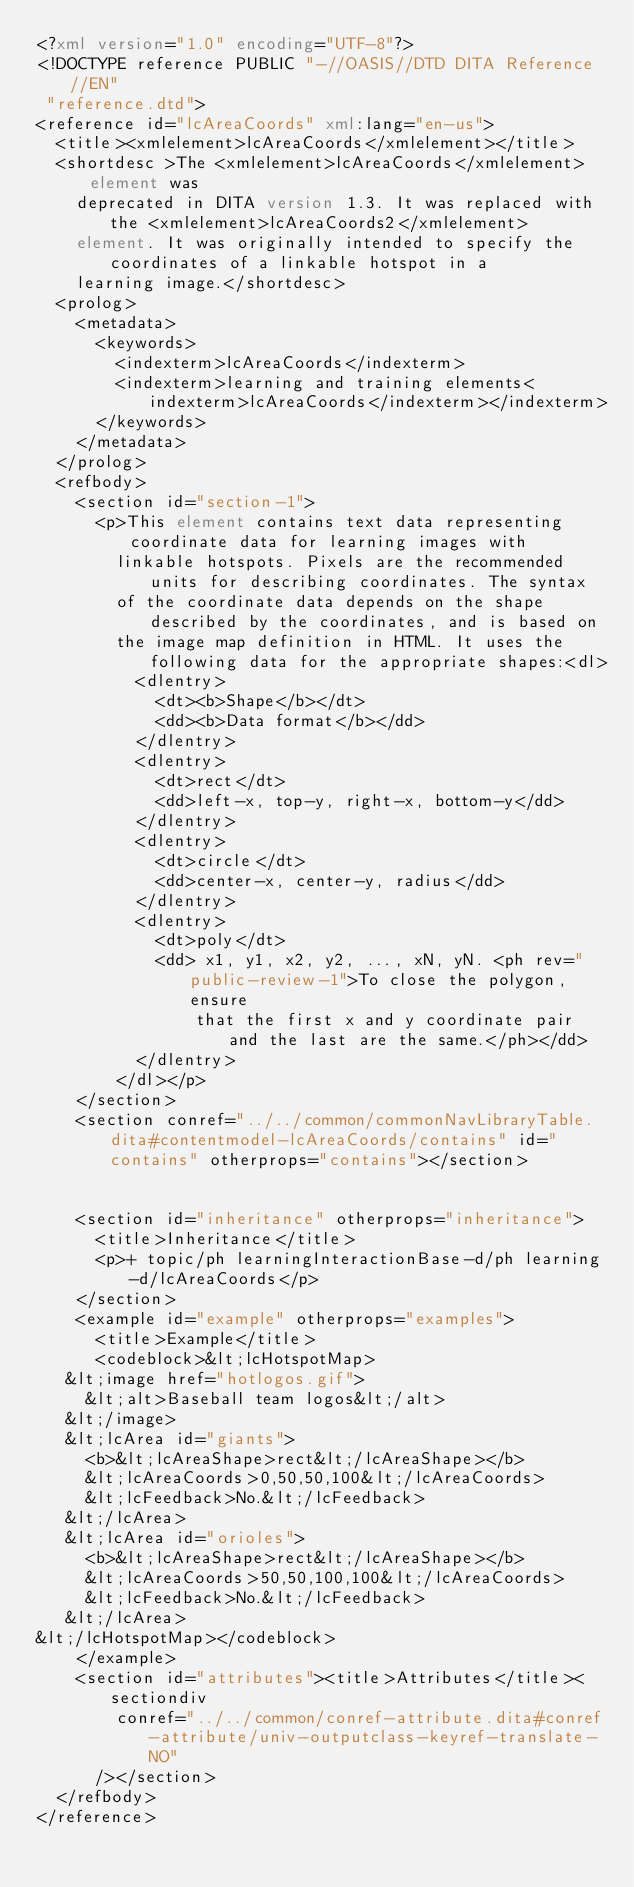<code> <loc_0><loc_0><loc_500><loc_500><_XML_><?xml version="1.0" encoding="UTF-8"?>
<!DOCTYPE reference PUBLIC "-//OASIS//DTD DITA Reference//EN"
 "reference.dtd">
<reference id="lcAreaCoords" xml:lang="en-us">
  <title><xmlelement>lcAreaCoords</xmlelement></title>
  <shortdesc >The <xmlelement>lcAreaCoords</xmlelement> element was
    deprecated in DITA version 1.3. It was replaced with the <xmlelement>lcAreaCoords2</xmlelement>
    element. It was originally intended to specify the coordinates of a linkable hotspot in a
    learning image.</shortdesc>
  <prolog>
    <metadata>
      <keywords>
        <indexterm>lcAreaCoords</indexterm>
        <indexterm>learning and training elements<indexterm>lcAreaCoords</indexterm></indexterm>
      </keywords>
    </metadata>
  </prolog>
  <refbody>
    <section id="section-1">
      <p>This element contains text data representing coordinate data for learning images with
        linkable hotspots. Pixels are the recommended units for describing coordinates. The syntax
        of the coordinate data depends on the shape described by the coordinates, and is based on
        the image map definition in HTML. It uses the following data for the appropriate shapes:<dl>
          <dlentry>
            <dt><b>Shape</b></dt>
            <dd><b>Data format</b></dd>
          </dlentry>
          <dlentry>
            <dt>rect</dt>
            <dd>left-x, top-y, right-x, bottom-y</dd>
          </dlentry>
          <dlentry>
            <dt>circle</dt>
            <dd>center-x, center-y, radius</dd>
          </dlentry>
          <dlentry>
            <dt>poly</dt>
            <dd> x1, y1, x2, y2, ..., xN, yN. <ph rev="public-review-1">To close the polygon, ensure
                that the first x and y coordinate pair and the last are the same.</ph></dd>
          </dlentry>
        </dl></p>
    </section>
    <section conref="../../common/commonNavLibraryTable.dita#contentmodel-lcAreaCoords/contains" id="contains" otherprops="contains"></section>
    

    <section id="inheritance" otherprops="inheritance">
      <title>Inheritance</title>
      <p>+ topic/ph learningInteractionBase-d/ph learning-d/lcAreaCoords</p>
    </section>
    <example id="example" otherprops="examples">
      <title>Example</title>
      <codeblock>&lt;lcHotspotMap>
   &lt;image href="hotlogos.gif">
     &lt;alt>Baseball team logos&lt;/alt>
   &lt;/image>
   &lt;lcArea id="giants">
     <b>&lt;lcAreaShape>rect&lt;/lcAreaShape></b>
     &lt;lcAreaCoords>0,50,50,100&lt;/lcAreaCoords>
     &lt;lcFeedback>No.&lt;/lcFeedback>
   &lt;/lcArea>
   &lt;lcArea id="orioles">
     <b>&lt;lcAreaShape>rect&lt;/lcAreaShape></b>
     &lt;lcAreaCoords>50,50,100,100&lt;/lcAreaCoords>
     &lt;lcFeedback>No.&lt;/lcFeedback>
   &lt;/lcArea>
&lt;/lcHotspotMap></codeblock>
    </example>
    <section id="attributes"><title>Attributes</title><sectiondiv
        conref="../../common/conref-attribute.dita#conref-attribute/univ-outputclass-keyref-translate-NO"
      /></section>
  </refbody>
</reference>

</code> 